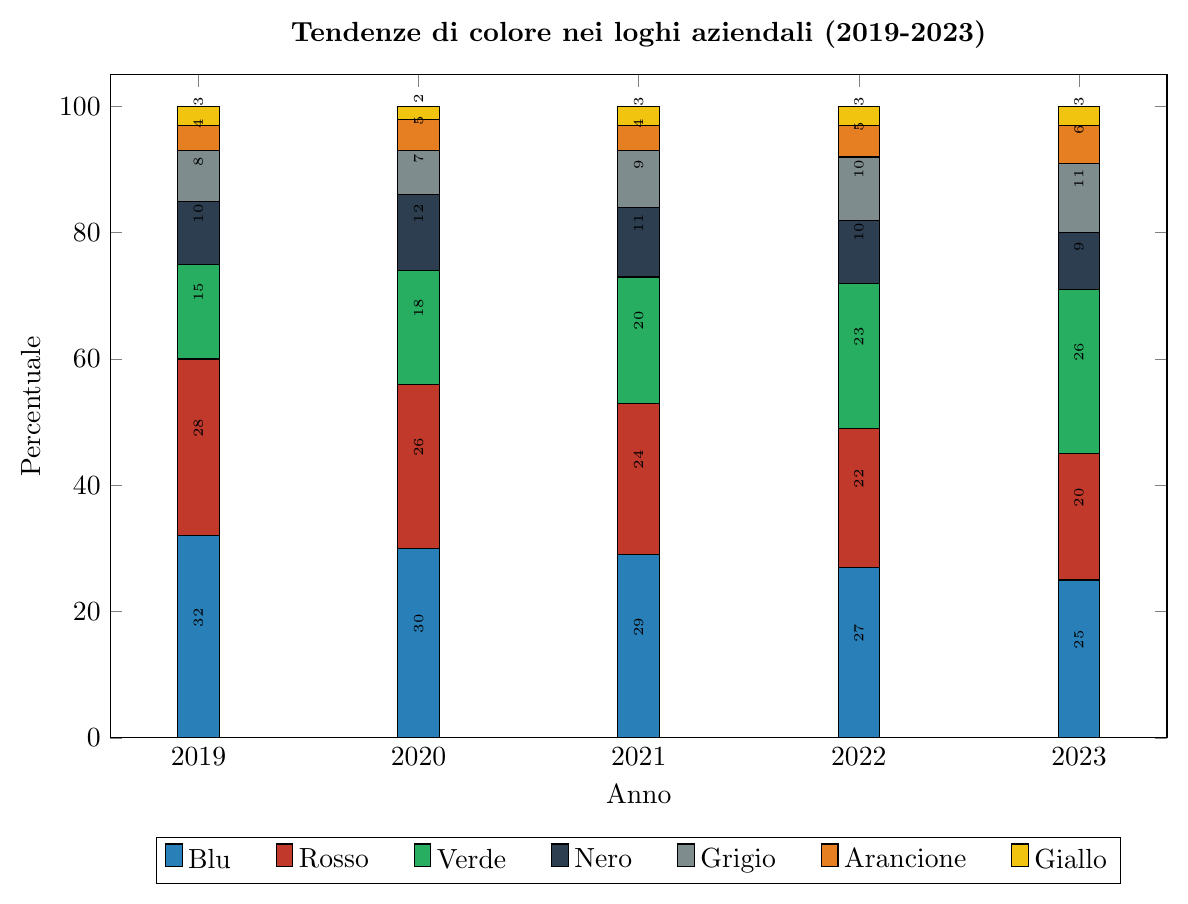Which color trend remained constant in usage percentage across the years? Looking at each year's data, only the color yellow maintained a constant percentage of usage across the years, which is 3%.
Answer: Yellow Which color had the highest percentage in 2023, and what was it? In 2023, the color with the highest percentage is green, with a value of 26%. By examining the heights of the bars for each color in 2023, green is the tallest.
Answer: Green with 26% How did the percentage usage of blue change from 2019 to 2023? In 2019, blue had a percentage of use of 32%. By 2023, this decreased to 25%. Therefore, the change in percentage is 32 - 25 = 7%.
Answer: Decreased by 7% What is the sum of the percentages of red and green in 2021? In 2021, the percentage of red is 24% and green is 20%. Adding these together, 24 + 20 = 44%.
Answer: 44% Which color saw the largest overall increase in percentage from 2019 to 2023? To find the color with the largest overall increase, we calculate the difference for each color between 2019 and 2023. Blue: 32 - 25 = -7%, Red: 28 - 20 = -8%, Green: 26 - 15 = 11%, Black: 10 - 9 = -1%, Gray: 11 - 8 = 3%, Orange: 6 - 4 = 2%, Yellow: 3 - 3 = 0%. Green had the largest increase, from 15% to 26%, an increase of 11%.
Answer: Green Which year had the lowest total percentage for red and black combined? Summing the percentages for red and black for each year, we get: 2019: 28 + 10 = 38%, 2020: 26 + 12 = 38%, 2021: 24 + 11 = 35%, 2022: 22 + 10 = 32%, 2023: 20 + 9 = 29%. The year with the lowest total percentage for red and black combined is 2023, with 29%.
Answer: 2023 How many colors had an increasing trend from 2019 to 2023? Looking at the data: Blue decreased (32 to 25), Red decreased (28 to 20), Green increased (15 to 26), Black decreased (10 to 9), Gray increased (8 to 11), Orange increased (4 to 6), Yellow remained the same (3). Therefore, green, gray, and orange are the colors with increasing trends from 2019 to 2023, so three colors had an increasing trend.
Answer: 3 What was the total percentage across all colors in 2022? Adding up the percentages for each color in 2022, we get: 27 (Blue) + 22 (Red) + 23 (Green) + 10 (Black) + 10 (Gray) + 5 (Orange) + 3 (Yellow) = 100%.
Answer: 100% 